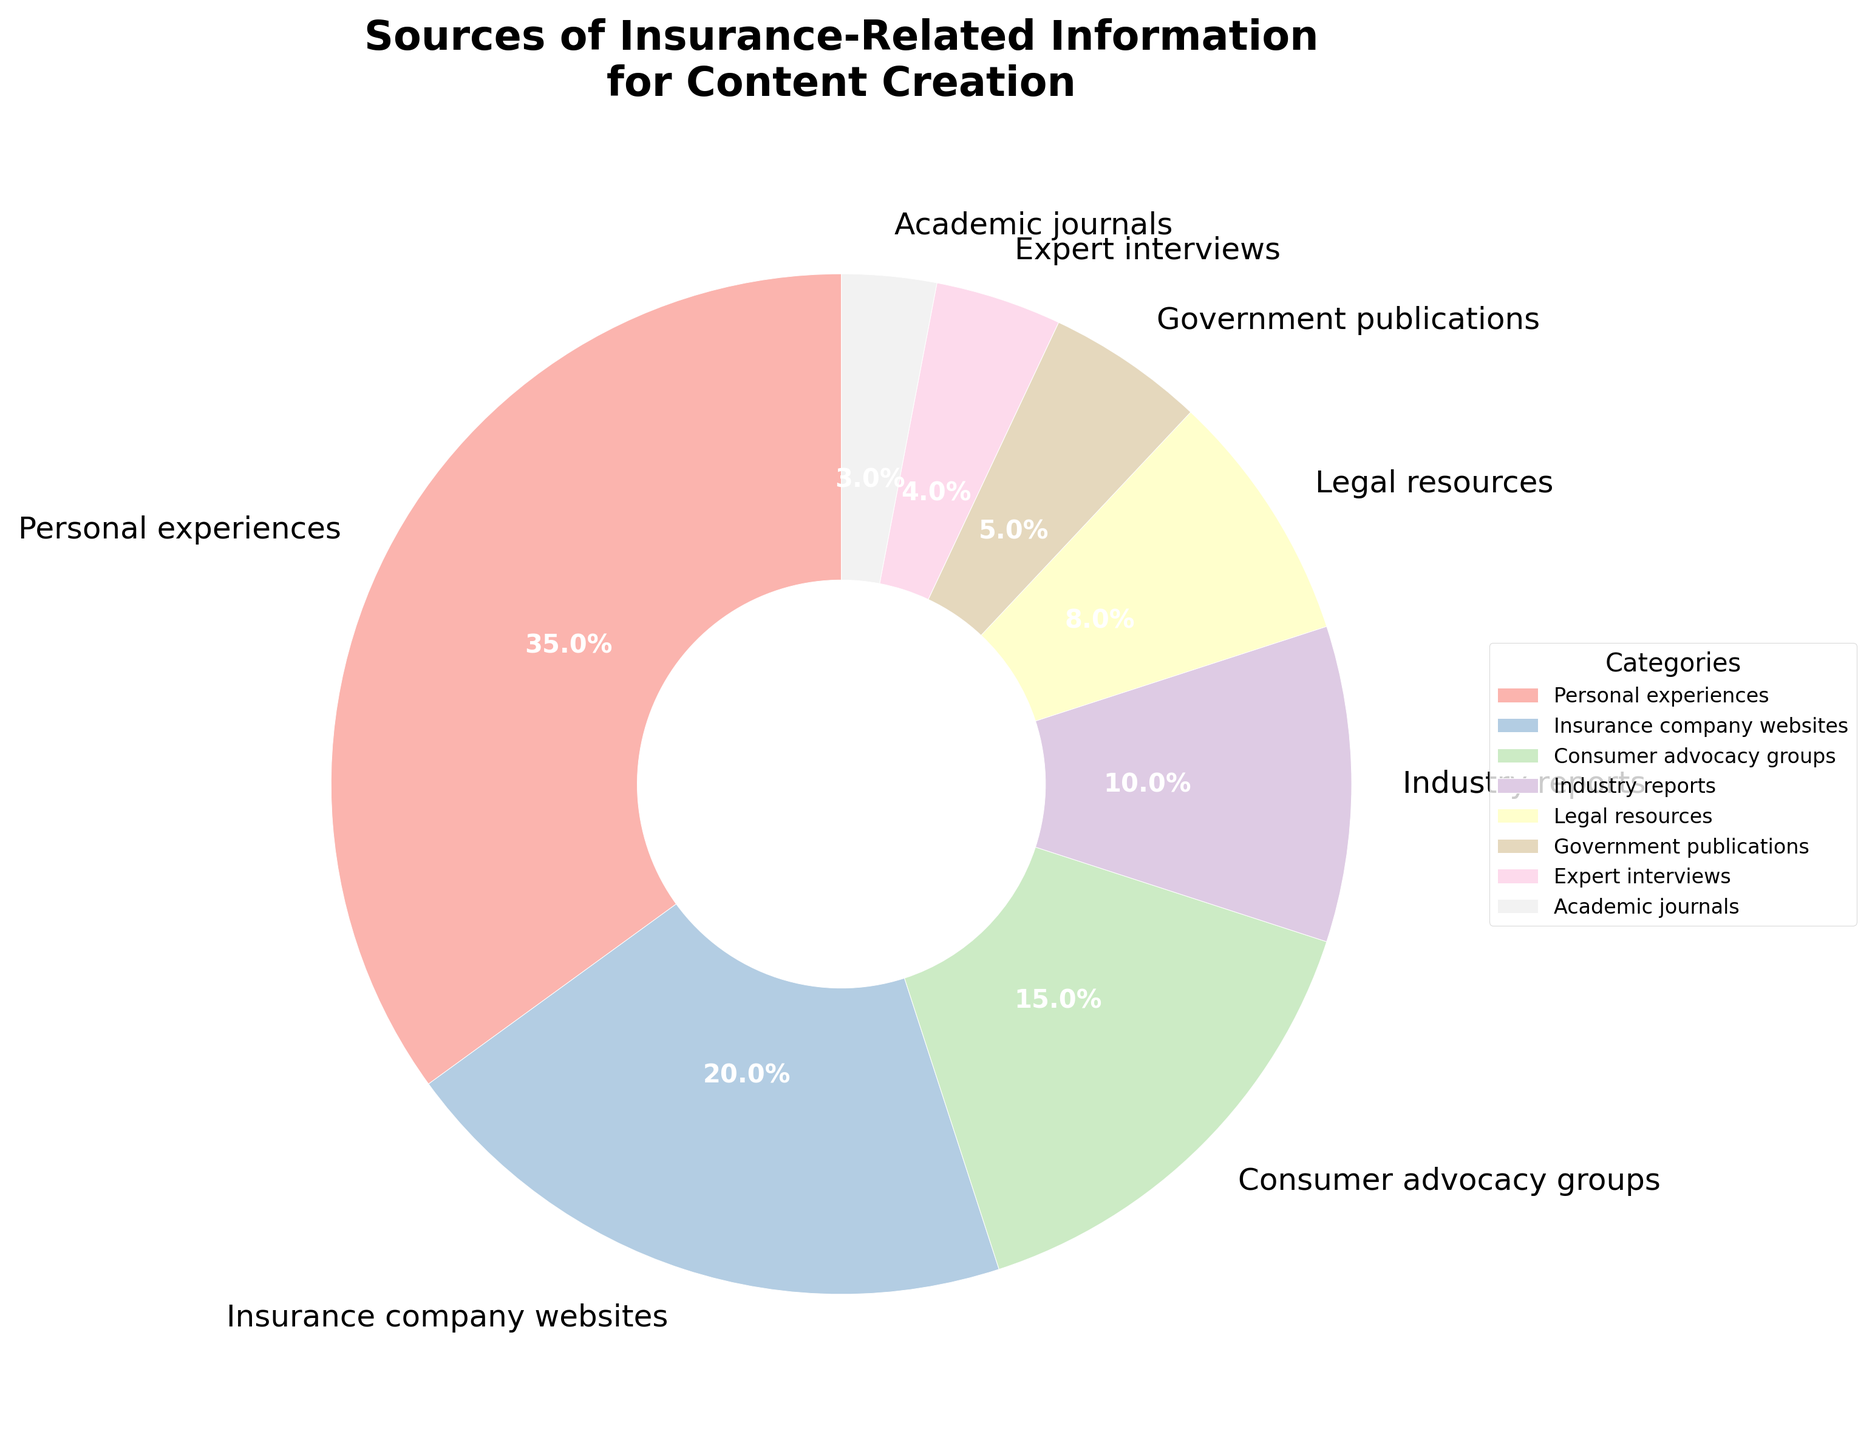What's the largest source of insurance-related information for content creation? The largest segment in the pie chart, representing 35%, corresponds to personal experiences. Therefore, personal experiences are the largest source.
Answer: Personal experiences Which source contributes more information: consumer advocacy groups or government publications? According to the pie chart, consumer advocacy groups contribute 15% while government publications contribute 5%. Therefore, consumer advocacy groups contribute more information.
Answer: Consumer advocacy groups What's the combined percentage of information from legal resources and expert interviews? The percentage for legal resources is 8% and for expert interviews is 4%. Their combined percentage is 8% + 4% = 12%.
Answer: 12% How many sources contribute less than 10% each? The sources with contributions less than 10% are industry reports (10%), legal resources (8%), government publications (5%), expert interviews (4%), and academic journals (3%). There are 5 such sources.
Answer: 5 Which source has the smallest contribution? The smallest segment in the pie chart, representing 3%, corresponds to academic journals. So, academic journals have the smallest contribution.
Answer: Academic journals Is the percentage of information from insurance company websites higher or lower than the sum of legal resources and government publications? Insurance company websites contribute 20%. Legal resources and government publications contribute 8% + 5% = 13%. Therefore, insurance company websites contribute more.
Answer: Higher If the percentage of information from industry reports increased by 5%, what percentage would it then represent? Industry reports currently contribute 10%. If increased by 5%, it would be 10% + 5% = 15%.
Answer: 15% How does the combined percentage of personal experiences and insurance company websites compare with the combined percentage of consumer advocacy groups and industry reports? Personal experiences and insurance company websites together contribute 35% + 20% = 55%. Consumer advocacy groups and industry reports together contribute 15% + 10% = 25%. Therefore, the combined percentage of personal experiences and insurance company websites is higher.
Answer: Higher Which sources combined contribute exactly half of the total information? Personal experiences (35%) and insurance company websites (20%) together make 35% + 20% = 55%, but this exceeds 50%. Reviewing the smaller combinations, legal resources (8%) and expert interviews (4%) add up to only 12%. Checking all pairs: no combination exact matches 50%.
Answer: None 